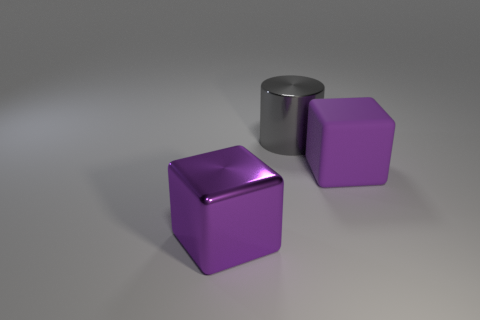Add 3 large gray things. How many objects exist? 6 Subtract all cylinders. How many objects are left? 2 Subtract 1 cubes. How many cubes are left? 1 Subtract all cyan metallic spheres. Subtract all gray cylinders. How many objects are left? 2 Add 2 big purple matte cubes. How many big purple matte cubes are left? 3 Add 1 big green metal cylinders. How many big green metal cylinders exist? 1 Subtract 0 cyan cylinders. How many objects are left? 3 Subtract all blue cylinders. Subtract all blue cubes. How many cylinders are left? 1 